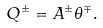Convert formula to latex. <formula><loc_0><loc_0><loc_500><loc_500>Q ^ { \pm } = A ^ { \pm } \theta ^ { \mp } .</formula> 